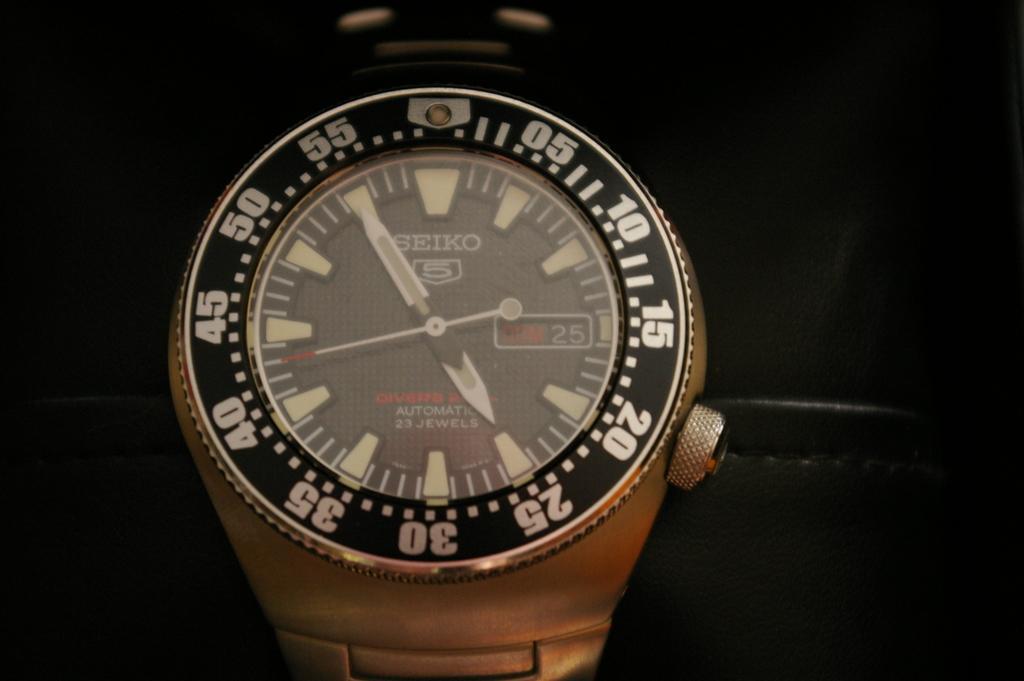Describe this image in one or two sentences. This looks like a wrist watch. This is the dial with numbers on it. I can see the minutes, hours and seconds hands. This is the crown attached to the watch. The background looks dark. 